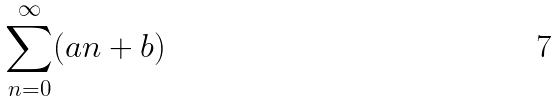<formula> <loc_0><loc_0><loc_500><loc_500>\sum _ { n = 0 } ^ { \infty } ( a n + b )</formula> 